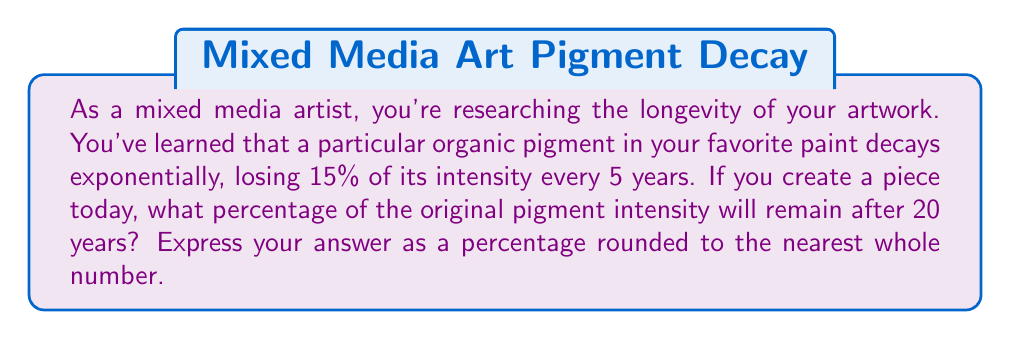Can you solve this math problem? Let's approach this step-by-step:

1) First, we need to determine the decay factor for each 5-year period. If 15% is lost, then 85% remains after each 5-year period.
   
   Decay factor = $1 - 0.15 = 0.85$

2) We want to know the intensity after 20 years, which is 4 periods of 5 years.

3) The exponential decay formula is:

   $$A = A_0 \cdot r^t$$

   Where:
   $A$ is the final amount
   $A_0$ is the initial amount (100% in this case)
   $r$ is the decay factor (0.85)
   $t$ is the number of time periods (4)

4) Plugging in our values:

   $$A = 100 \cdot 0.85^4$$

5) Calculate:
   $$A = 100 \cdot 0.5220 = 52.20\%$$

6) Rounding to the nearest whole number:
   52.20% rounds to 52%

Therefore, after 20 years, 52% of the original pigment intensity will remain.
Answer: 52% 